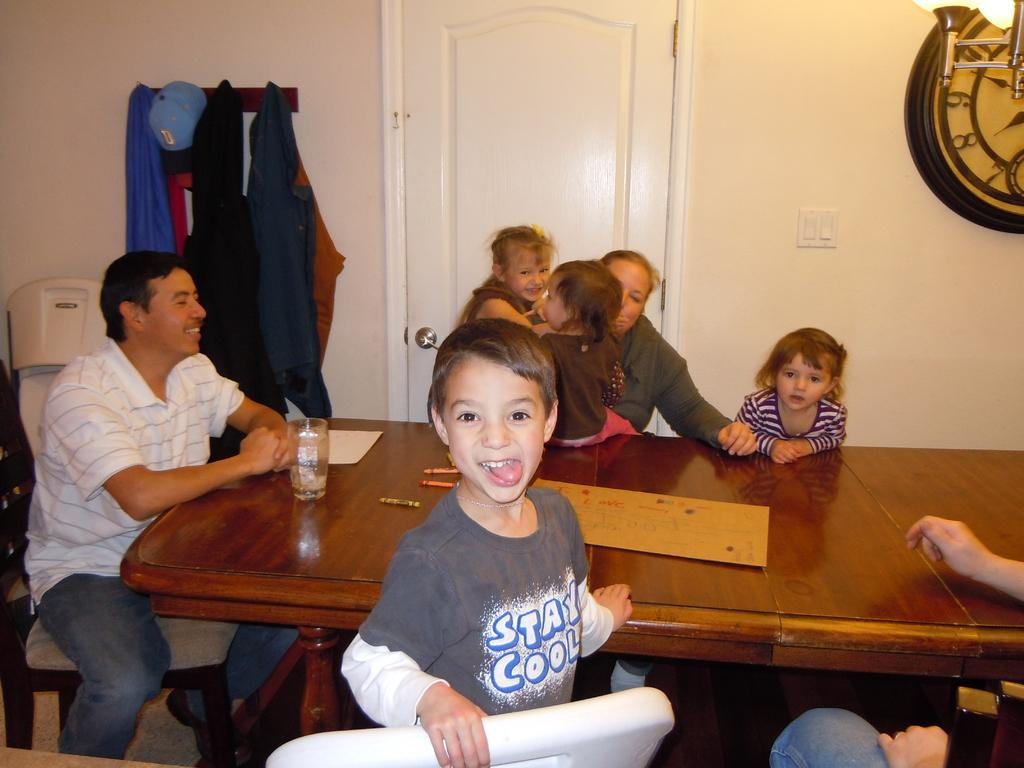How many people are in the image? There are two persons in the image. What are the children doing in the image? The children are sitting in front of a table in the image. What is the main piece of furniture in the image? There is a table in the image. What are the children sitting on in the image? There are chairs in the image. What can be seen hanging on the wall in the image? There is a clothes hanging on a wall in the image. What time-telling device is present in the image? There is a wall clock in the image. What type of governor is visible in the image? There is no governor present in the image. What type of beam can be seen supporting the roof in the image? There is no beam visible in the image, nor is there a roof shown. 